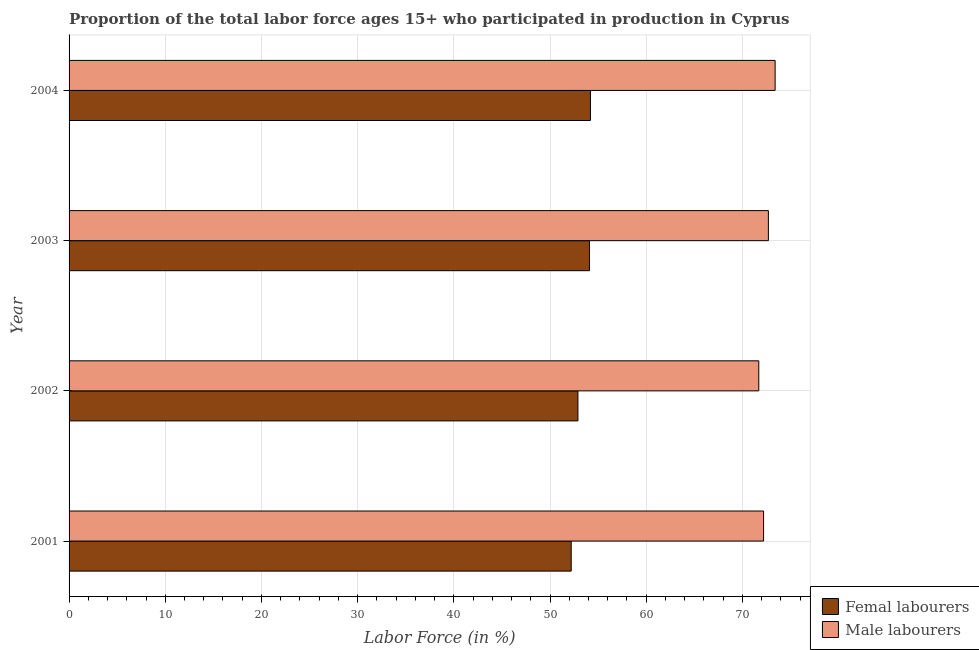How many different coloured bars are there?
Offer a terse response. 2. Are the number of bars per tick equal to the number of legend labels?
Keep it short and to the point. Yes. Are the number of bars on each tick of the Y-axis equal?
Your response must be concise. Yes. How many bars are there on the 1st tick from the top?
Your answer should be very brief. 2. How many bars are there on the 2nd tick from the bottom?
Offer a terse response. 2. What is the label of the 2nd group of bars from the top?
Provide a short and direct response. 2003. What is the percentage of female labor force in 2003?
Provide a short and direct response. 54.1. Across all years, what is the maximum percentage of female labor force?
Keep it short and to the point. 54.2. Across all years, what is the minimum percentage of female labor force?
Keep it short and to the point. 52.2. In which year was the percentage of male labour force maximum?
Ensure brevity in your answer.  2004. What is the total percentage of female labor force in the graph?
Your response must be concise. 213.4. What is the difference between the percentage of male labour force in 2001 and the percentage of female labor force in 2002?
Offer a very short reply. 19.3. What is the average percentage of male labour force per year?
Offer a very short reply. 72.5. In the year 2002, what is the difference between the percentage of female labor force and percentage of male labour force?
Your response must be concise. -18.8. In how many years, is the percentage of female labor force greater than 28 %?
Your answer should be very brief. 4. What is the ratio of the percentage of female labor force in 2002 to that in 2003?
Make the answer very short. 0.98. Is the difference between the percentage of female labor force in 2001 and 2003 greater than the difference between the percentage of male labour force in 2001 and 2003?
Offer a terse response. No. Is the sum of the percentage of male labour force in 2002 and 2004 greater than the maximum percentage of female labor force across all years?
Your answer should be very brief. Yes. What does the 2nd bar from the top in 2001 represents?
Provide a succinct answer. Femal labourers. What does the 2nd bar from the bottom in 2004 represents?
Your answer should be compact. Male labourers. How many years are there in the graph?
Provide a succinct answer. 4. Are the values on the major ticks of X-axis written in scientific E-notation?
Your answer should be very brief. No. Does the graph contain grids?
Make the answer very short. Yes. Where does the legend appear in the graph?
Give a very brief answer. Bottom right. How many legend labels are there?
Your response must be concise. 2. What is the title of the graph?
Offer a very short reply. Proportion of the total labor force ages 15+ who participated in production in Cyprus. Does "Rural Population" appear as one of the legend labels in the graph?
Ensure brevity in your answer.  No. What is the label or title of the X-axis?
Your response must be concise. Labor Force (in %). What is the label or title of the Y-axis?
Offer a terse response. Year. What is the Labor Force (in %) of Femal labourers in 2001?
Offer a very short reply. 52.2. What is the Labor Force (in %) of Male labourers in 2001?
Your response must be concise. 72.2. What is the Labor Force (in %) in Femal labourers in 2002?
Keep it short and to the point. 52.9. What is the Labor Force (in %) in Male labourers in 2002?
Your answer should be very brief. 71.7. What is the Labor Force (in %) in Femal labourers in 2003?
Keep it short and to the point. 54.1. What is the Labor Force (in %) in Male labourers in 2003?
Give a very brief answer. 72.7. What is the Labor Force (in %) of Femal labourers in 2004?
Give a very brief answer. 54.2. What is the Labor Force (in %) in Male labourers in 2004?
Give a very brief answer. 73.4. Across all years, what is the maximum Labor Force (in %) in Femal labourers?
Keep it short and to the point. 54.2. Across all years, what is the maximum Labor Force (in %) in Male labourers?
Ensure brevity in your answer.  73.4. Across all years, what is the minimum Labor Force (in %) in Femal labourers?
Offer a very short reply. 52.2. Across all years, what is the minimum Labor Force (in %) of Male labourers?
Offer a terse response. 71.7. What is the total Labor Force (in %) in Femal labourers in the graph?
Provide a succinct answer. 213.4. What is the total Labor Force (in %) in Male labourers in the graph?
Keep it short and to the point. 290. What is the difference between the Labor Force (in %) of Male labourers in 2001 and that in 2002?
Your response must be concise. 0.5. What is the difference between the Labor Force (in %) in Male labourers in 2001 and that in 2003?
Your answer should be compact. -0.5. What is the difference between the Labor Force (in %) of Femal labourers in 2001 and that in 2004?
Make the answer very short. -2. What is the difference between the Labor Force (in %) of Male labourers in 2001 and that in 2004?
Give a very brief answer. -1.2. What is the difference between the Labor Force (in %) in Femal labourers in 2002 and that in 2003?
Ensure brevity in your answer.  -1.2. What is the difference between the Labor Force (in %) of Male labourers in 2002 and that in 2003?
Provide a succinct answer. -1. What is the difference between the Labor Force (in %) of Femal labourers in 2002 and that in 2004?
Offer a very short reply. -1.3. What is the difference between the Labor Force (in %) of Male labourers in 2003 and that in 2004?
Provide a succinct answer. -0.7. What is the difference between the Labor Force (in %) of Femal labourers in 2001 and the Labor Force (in %) of Male labourers in 2002?
Provide a succinct answer. -19.5. What is the difference between the Labor Force (in %) in Femal labourers in 2001 and the Labor Force (in %) in Male labourers in 2003?
Your answer should be compact. -20.5. What is the difference between the Labor Force (in %) in Femal labourers in 2001 and the Labor Force (in %) in Male labourers in 2004?
Ensure brevity in your answer.  -21.2. What is the difference between the Labor Force (in %) of Femal labourers in 2002 and the Labor Force (in %) of Male labourers in 2003?
Your response must be concise. -19.8. What is the difference between the Labor Force (in %) in Femal labourers in 2002 and the Labor Force (in %) in Male labourers in 2004?
Your answer should be very brief. -20.5. What is the difference between the Labor Force (in %) in Femal labourers in 2003 and the Labor Force (in %) in Male labourers in 2004?
Offer a terse response. -19.3. What is the average Labor Force (in %) in Femal labourers per year?
Your answer should be compact. 53.35. What is the average Labor Force (in %) in Male labourers per year?
Provide a short and direct response. 72.5. In the year 2002, what is the difference between the Labor Force (in %) of Femal labourers and Labor Force (in %) of Male labourers?
Offer a very short reply. -18.8. In the year 2003, what is the difference between the Labor Force (in %) in Femal labourers and Labor Force (in %) in Male labourers?
Ensure brevity in your answer.  -18.6. In the year 2004, what is the difference between the Labor Force (in %) of Femal labourers and Labor Force (in %) of Male labourers?
Your answer should be very brief. -19.2. What is the ratio of the Labor Force (in %) in Femal labourers in 2001 to that in 2003?
Your response must be concise. 0.96. What is the ratio of the Labor Force (in %) in Femal labourers in 2001 to that in 2004?
Offer a very short reply. 0.96. What is the ratio of the Labor Force (in %) in Male labourers in 2001 to that in 2004?
Give a very brief answer. 0.98. What is the ratio of the Labor Force (in %) in Femal labourers in 2002 to that in 2003?
Your answer should be very brief. 0.98. What is the ratio of the Labor Force (in %) of Male labourers in 2002 to that in 2003?
Give a very brief answer. 0.99. What is the ratio of the Labor Force (in %) of Male labourers in 2002 to that in 2004?
Provide a short and direct response. 0.98. What is the ratio of the Labor Force (in %) in Femal labourers in 2003 to that in 2004?
Ensure brevity in your answer.  1. What is the ratio of the Labor Force (in %) of Male labourers in 2003 to that in 2004?
Your answer should be compact. 0.99. 